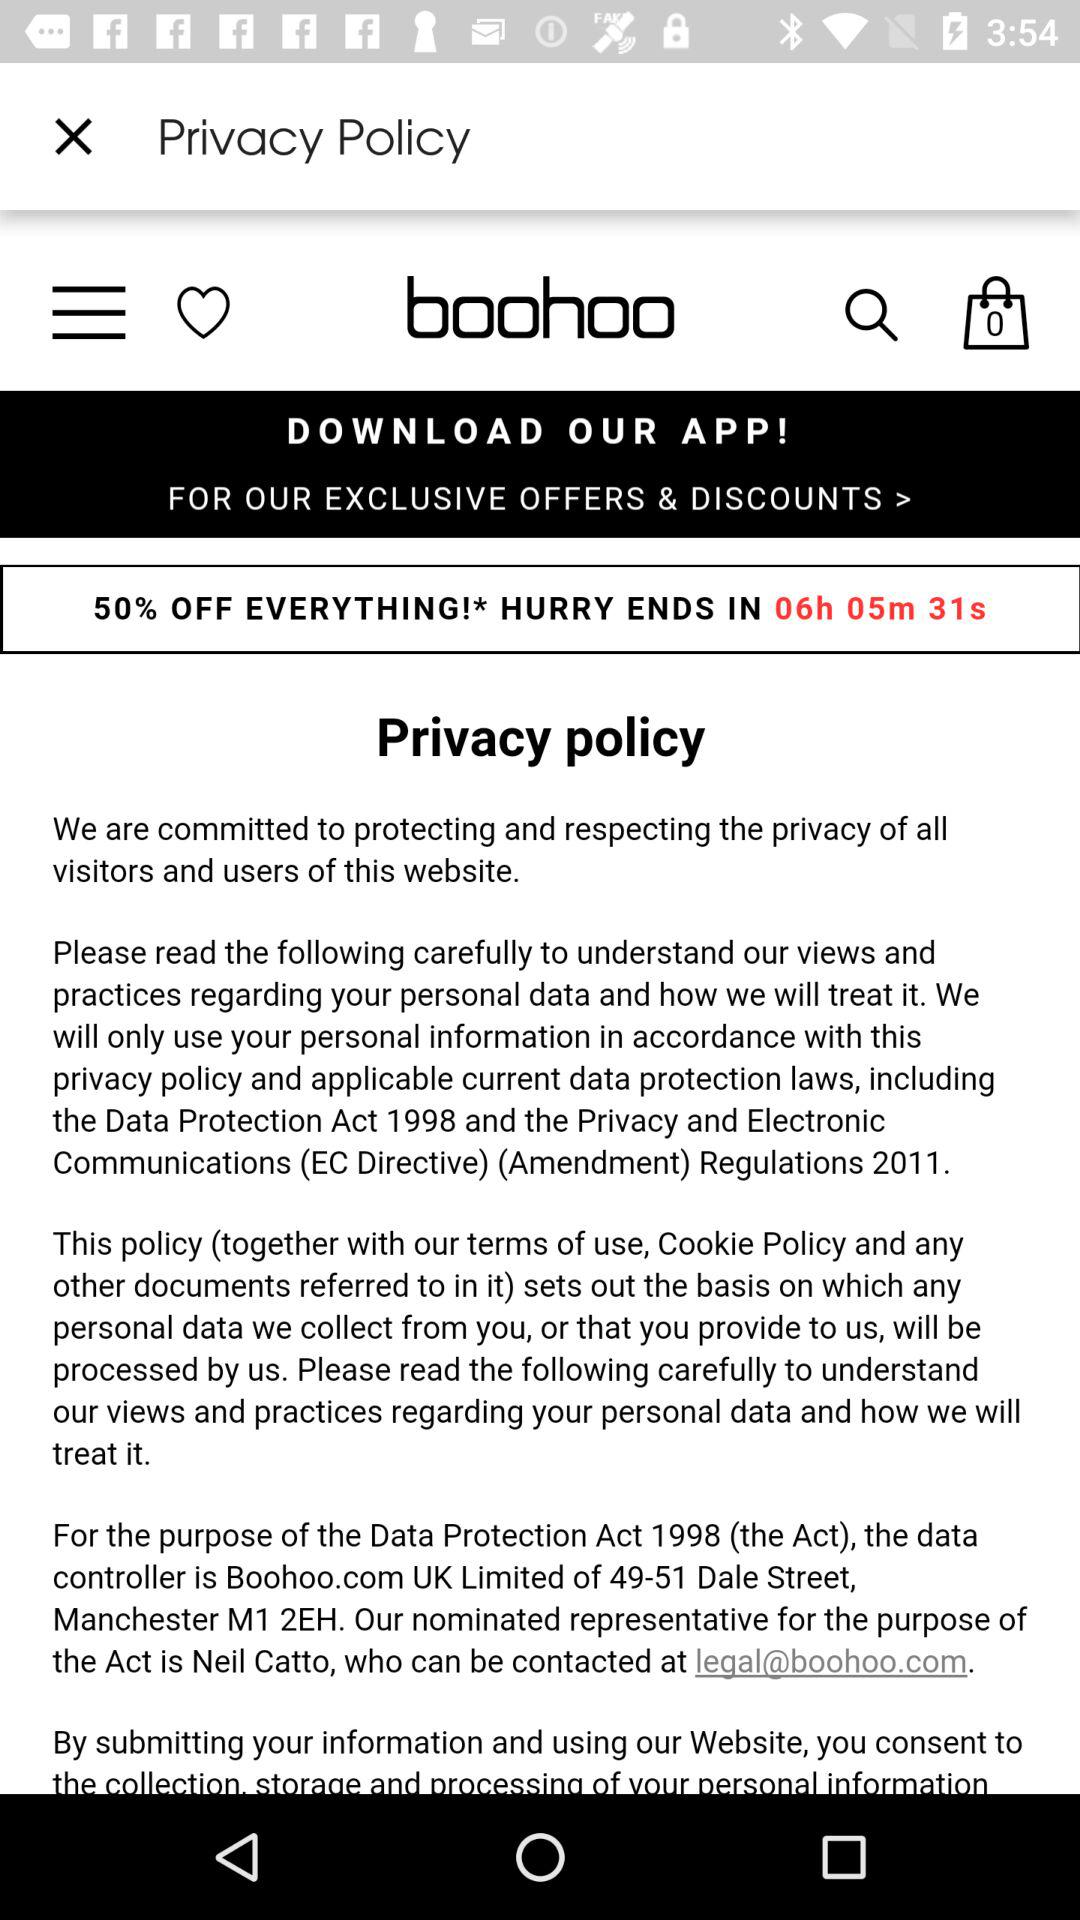What is the year of the data protection act? The year is 1998. 